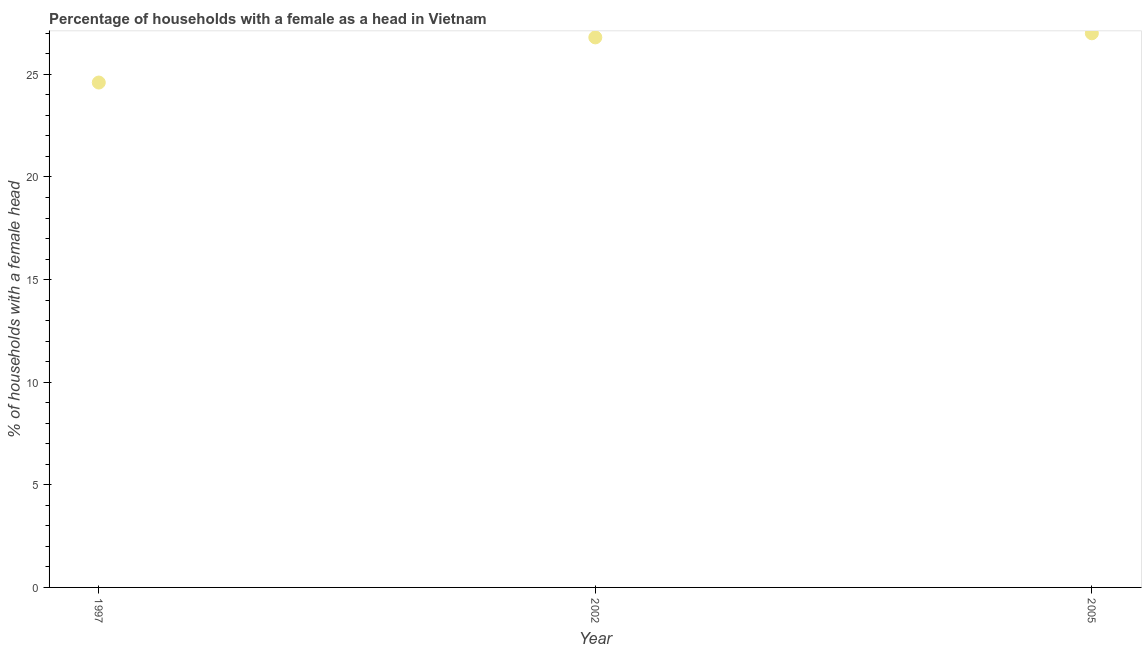What is the number of female supervised households in 1997?
Offer a very short reply. 24.6. Across all years, what is the maximum number of female supervised households?
Your answer should be very brief. 27. Across all years, what is the minimum number of female supervised households?
Provide a short and direct response. 24.6. In which year was the number of female supervised households maximum?
Your answer should be compact. 2005. What is the sum of the number of female supervised households?
Ensure brevity in your answer.  78.4. What is the difference between the number of female supervised households in 2002 and 2005?
Offer a terse response. -0.2. What is the average number of female supervised households per year?
Offer a terse response. 26.13. What is the median number of female supervised households?
Ensure brevity in your answer.  26.8. In how many years, is the number of female supervised households greater than 5 %?
Offer a very short reply. 3. Do a majority of the years between 2005 and 1997 (inclusive) have number of female supervised households greater than 1 %?
Ensure brevity in your answer.  No. What is the ratio of the number of female supervised households in 1997 to that in 2005?
Provide a succinct answer. 0.91. Is the difference between the number of female supervised households in 1997 and 2002 greater than the difference between any two years?
Give a very brief answer. No. What is the difference between the highest and the second highest number of female supervised households?
Your answer should be compact. 0.2. What is the difference between the highest and the lowest number of female supervised households?
Your answer should be very brief. 2.4. In how many years, is the number of female supervised households greater than the average number of female supervised households taken over all years?
Provide a succinct answer. 2. How many dotlines are there?
Your answer should be very brief. 1. What is the difference between two consecutive major ticks on the Y-axis?
Keep it short and to the point. 5. Does the graph contain any zero values?
Provide a short and direct response. No. What is the title of the graph?
Keep it short and to the point. Percentage of households with a female as a head in Vietnam. What is the label or title of the Y-axis?
Offer a very short reply. % of households with a female head. What is the % of households with a female head in 1997?
Offer a very short reply. 24.6. What is the % of households with a female head in 2002?
Offer a very short reply. 26.8. What is the % of households with a female head in 2005?
Offer a very short reply. 27. What is the difference between the % of households with a female head in 1997 and 2002?
Offer a terse response. -2.2. What is the ratio of the % of households with a female head in 1997 to that in 2002?
Your answer should be compact. 0.92. What is the ratio of the % of households with a female head in 1997 to that in 2005?
Provide a short and direct response. 0.91. 